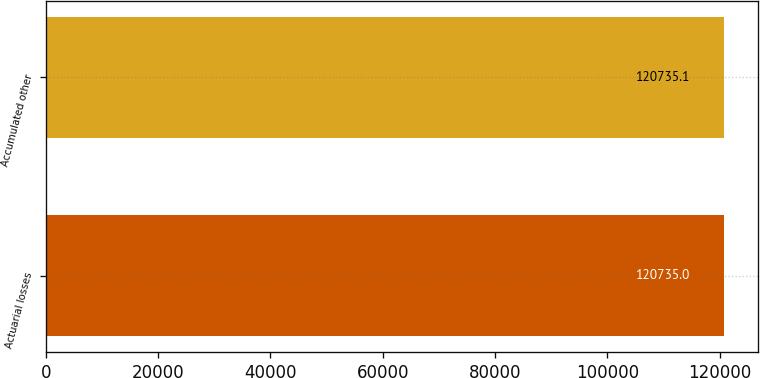<chart> <loc_0><loc_0><loc_500><loc_500><bar_chart><fcel>Actuarial losses<fcel>Accumulated other<nl><fcel>120735<fcel>120735<nl></chart> 